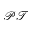<formula> <loc_0><loc_0><loc_500><loc_500>\mathcal { P T }</formula> 